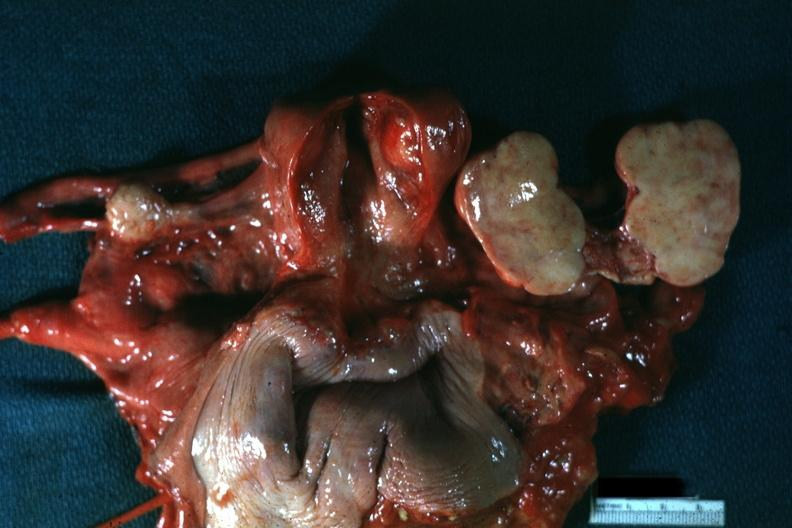s thecoma present?
Answer the question using a single word or phrase. Yes 